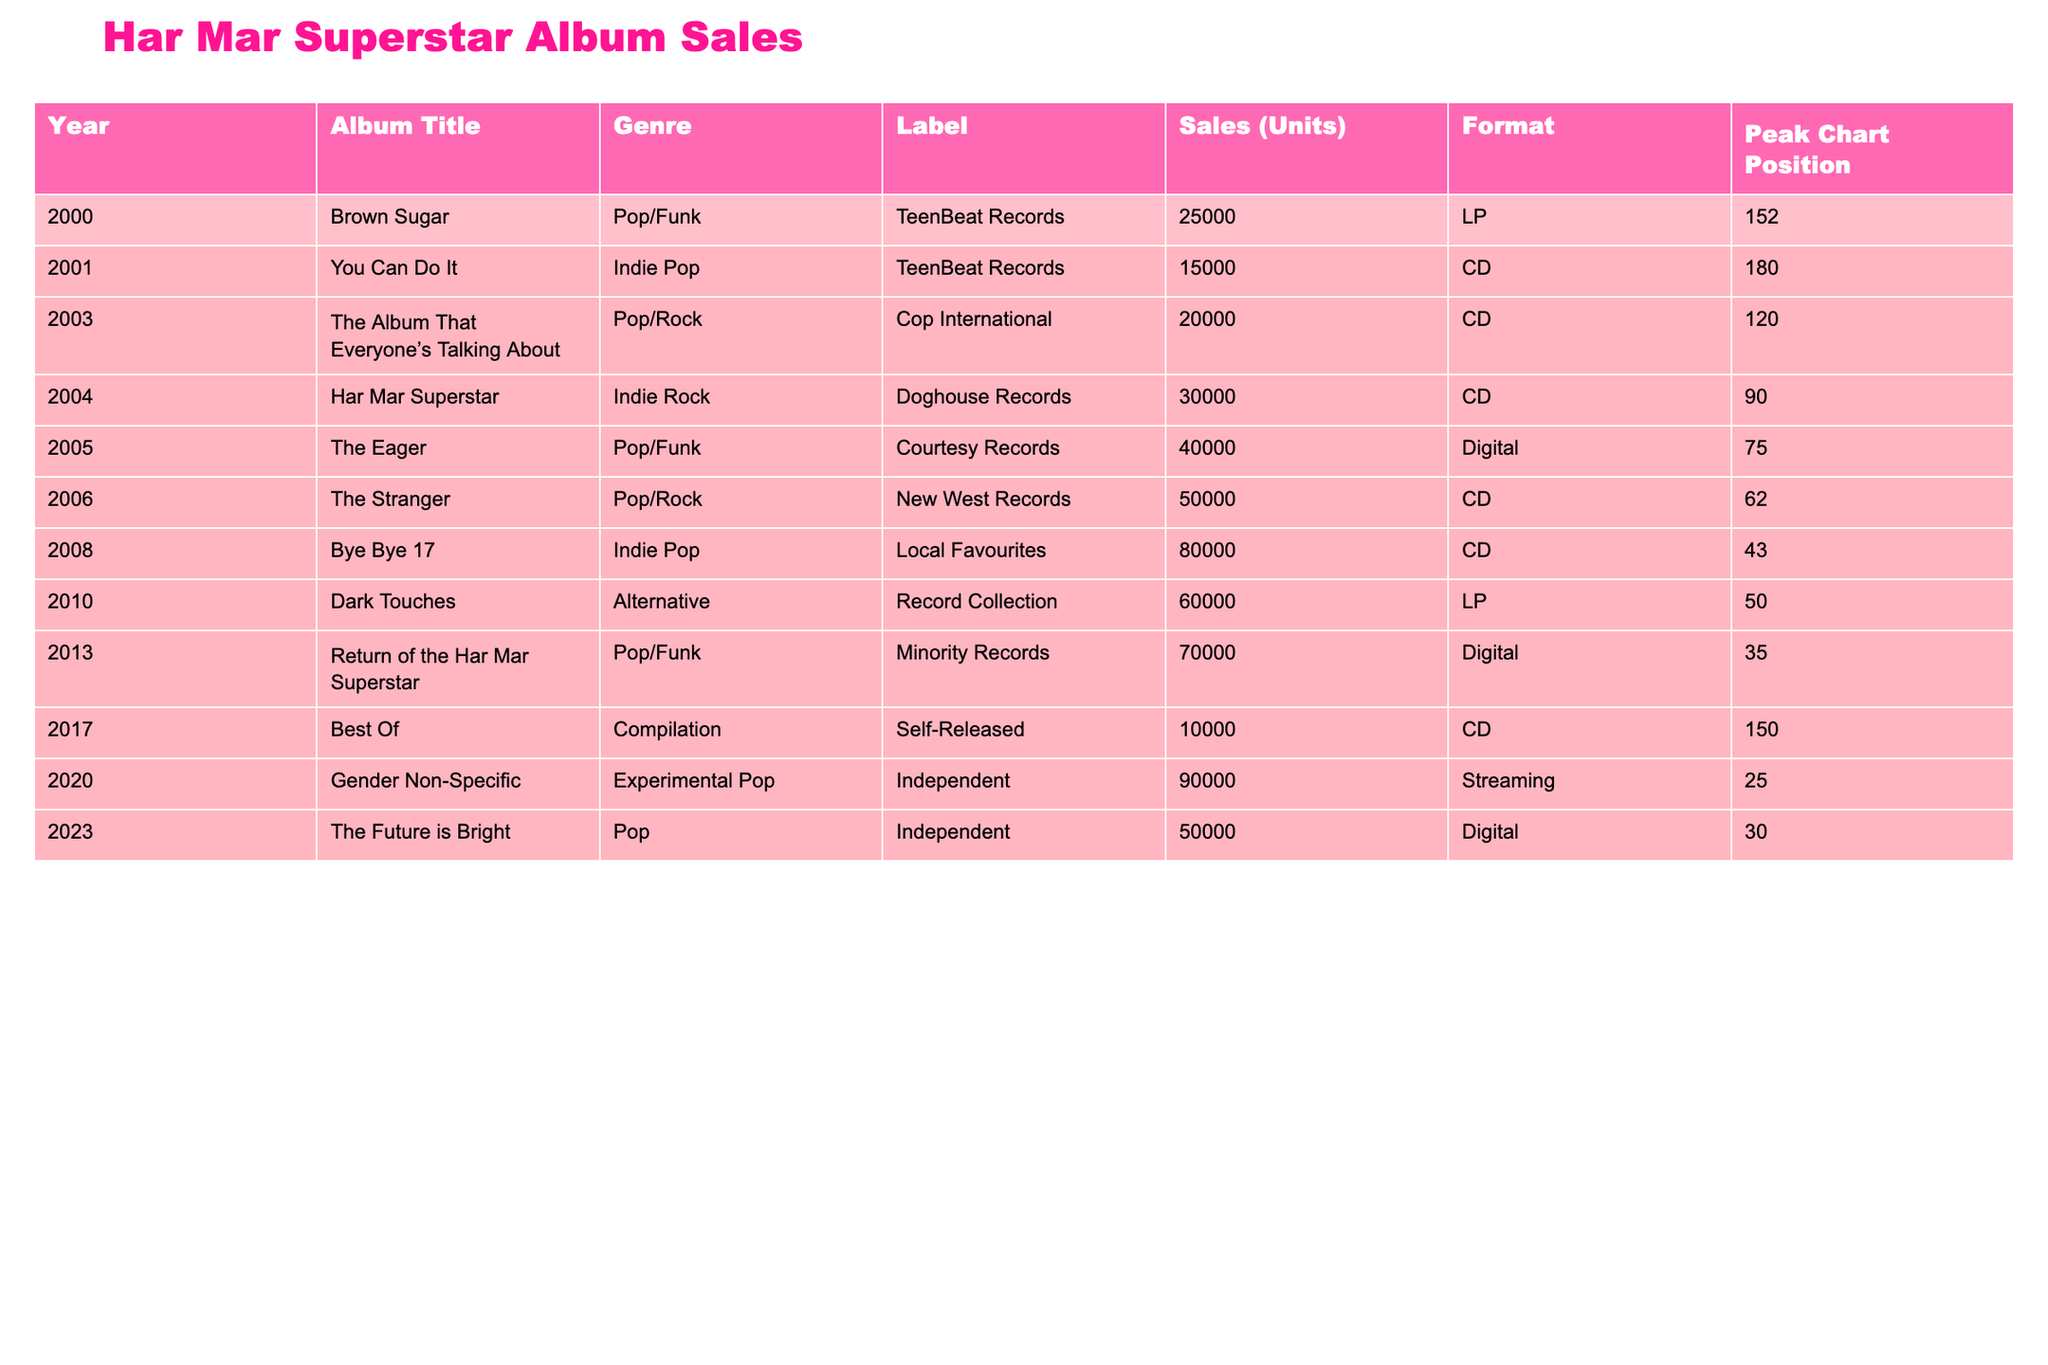What is the total sales of all albums released by Har Mar Superstar? To find the total sales, add the sales of each album: 25000 + 15000 + 20000 + 30000 + 40000 + 50000 + 80000 + 60000 + 70000 + 10000 + 90000 + 50000 = 390000
Answer: 390000 Which album had the highest sales? The album with the highest sales is "Gender Non-Specific" with 90000 units sold.
Answer: Gender Non-Specific What genre does the album "The Eager" belong to? The genre of the album "The Eager" is Pop/Funk as listed in the table.
Answer: Pop/Funk Was "Bye Bye 17" the first album to have sales over 70000 units? Yes, "Bye Bye 17" was the first album that reached over 70000 units with a total of 80000 units sold.
Answer: Yes What is the average sales of Har Mar Superstar albums? There are 12 albums listed with a total sales of 390000 units. Thus, the average sales = 390000 / 12 = 32500.
Answer: 32500 How many albums were released after 2010? The albums released after 2010 are "Return of the Har Mar Superstar" (2013), "Best Of" (2017), "Gender Non-Specific" (2020), and "The Future is Bright" (2023), totaling 4 albums.
Answer: 4 What was the peak chart position of "Har Mar Superstar"? The peak chart position of "Har Mar Superstar" was 90.
Answer: 90 Which album has the lowest sales and what is that number? The album with the lowest sales is "Best Of" with 10000 units sold.
Answer: 10000 Determine the trend of sales from 2000 to 2023. By analyzing the sales: 25000 (2000), 15000 (2001), increase to 20000 (2003), 30000 (2004), increase to 40000 (2005), 50000 (2006), spike at 80000 (2008), drop to 60000 (2010), then a rise to 70000 (2013), drop to 10000 (2017), and peak at 90000 (2020), with a final sales of 50000 (2023). The overall trend shows an initial increase, a peak in 2008, some fluctuations, and a notable dip in 2017.
Answer: The sales trend shows fluctuations with an overall increase until 2008, a decline in 2017, and rise again in 2020 How many albums are listed under the genre "Experimental Pop"? The table shows only one album under "Experimental Pop," which is "Gender Non-Specific."
Answer: 1 